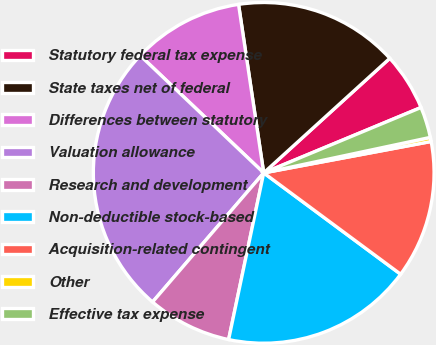<chart> <loc_0><loc_0><loc_500><loc_500><pie_chart><fcel>Statutory federal tax expense<fcel>State taxes net of federal<fcel>Differences between statutory<fcel>Valuation allowance<fcel>Research and development<fcel>Non-deductible stock-based<fcel>Acquisition-related contingent<fcel>Other<fcel>Effective tax expense<nl><fcel>5.47%<fcel>15.62%<fcel>10.55%<fcel>25.78%<fcel>8.01%<fcel>18.16%<fcel>13.09%<fcel>0.39%<fcel>2.93%<nl></chart> 